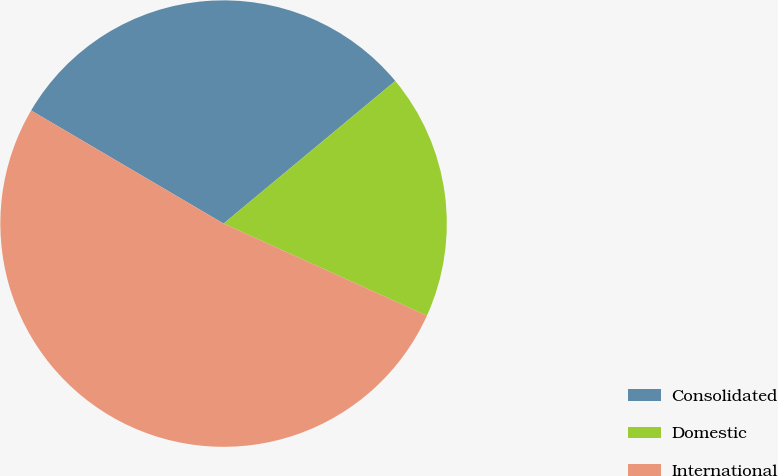Convert chart to OTSL. <chart><loc_0><loc_0><loc_500><loc_500><pie_chart><fcel>Consolidated<fcel>Domestic<fcel>International<nl><fcel>30.51%<fcel>17.8%<fcel>51.69%<nl></chart> 